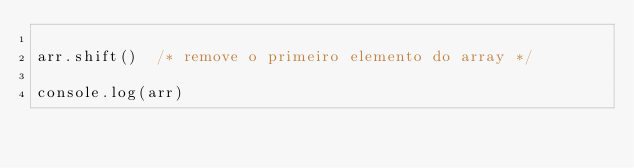Convert code to text. <code><loc_0><loc_0><loc_500><loc_500><_JavaScript_>
arr.shift()  /* remove o primeiro elemento do array */

console.log(arr)


</code> 